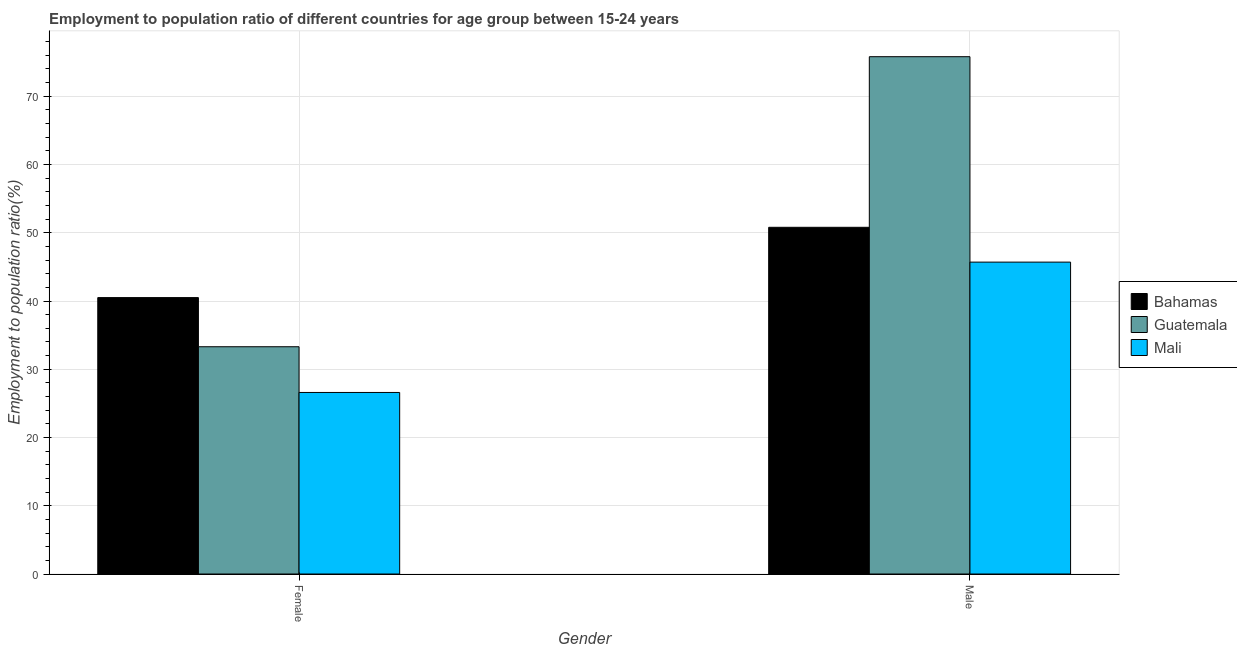How many groups of bars are there?
Offer a terse response. 2. Are the number of bars per tick equal to the number of legend labels?
Make the answer very short. Yes. Are the number of bars on each tick of the X-axis equal?
Keep it short and to the point. Yes. How many bars are there on the 2nd tick from the left?
Your response must be concise. 3. What is the label of the 2nd group of bars from the left?
Your response must be concise. Male. What is the employment to population ratio(female) in Mali?
Offer a terse response. 26.6. Across all countries, what is the maximum employment to population ratio(male)?
Give a very brief answer. 75.8. Across all countries, what is the minimum employment to population ratio(female)?
Offer a terse response. 26.6. In which country was the employment to population ratio(female) maximum?
Your answer should be very brief. Bahamas. In which country was the employment to population ratio(female) minimum?
Make the answer very short. Mali. What is the total employment to population ratio(female) in the graph?
Ensure brevity in your answer.  100.4. What is the difference between the employment to population ratio(female) in Bahamas and that in Mali?
Provide a short and direct response. 13.9. What is the difference between the employment to population ratio(female) in Bahamas and the employment to population ratio(male) in Guatemala?
Offer a terse response. -35.3. What is the average employment to population ratio(female) per country?
Ensure brevity in your answer.  33.47. What is the difference between the employment to population ratio(male) and employment to population ratio(female) in Bahamas?
Keep it short and to the point. 10.3. What is the ratio of the employment to population ratio(female) in Guatemala to that in Bahamas?
Your answer should be very brief. 0.82. In how many countries, is the employment to population ratio(male) greater than the average employment to population ratio(male) taken over all countries?
Offer a very short reply. 1. What does the 2nd bar from the left in Female represents?
Give a very brief answer. Guatemala. What does the 2nd bar from the right in Female represents?
Provide a short and direct response. Guatemala. Are all the bars in the graph horizontal?
Your response must be concise. No. What is the difference between two consecutive major ticks on the Y-axis?
Your answer should be compact. 10. Are the values on the major ticks of Y-axis written in scientific E-notation?
Offer a very short reply. No. Does the graph contain grids?
Provide a short and direct response. Yes. How are the legend labels stacked?
Offer a terse response. Vertical. What is the title of the graph?
Provide a succinct answer. Employment to population ratio of different countries for age group between 15-24 years. What is the label or title of the Y-axis?
Provide a succinct answer. Employment to population ratio(%). What is the Employment to population ratio(%) of Bahamas in Female?
Your response must be concise. 40.5. What is the Employment to population ratio(%) of Guatemala in Female?
Offer a terse response. 33.3. What is the Employment to population ratio(%) in Mali in Female?
Offer a very short reply. 26.6. What is the Employment to population ratio(%) of Bahamas in Male?
Your answer should be compact. 50.8. What is the Employment to population ratio(%) of Guatemala in Male?
Make the answer very short. 75.8. What is the Employment to population ratio(%) of Mali in Male?
Provide a succinct answer. 45.7. Across all Gender, what is the maximum Employment to population ratio(%) of Bahamas?
Make the answer very short. 50.8. Across all Gender, what is the maximum Employment to population ratio(%) in Guatemala?
Give a very brief answer. 75.8. Across all Gender, what is the maximum Employment to population ratio(%) in Mali?
Keep it short and to the point. 45.7. Across all Gender, what is the minimum Employment to population ratio(%) of Bahamas?
Give a very brief answer. 40.5. Across all Gender, what is the minimum Employment to population ratio(%) of Guatemala?
Provide a succinct answer. 33.3. Across all Gender, what is the minimum Employment to population ratio(%) in Mali?
Provide a short and direct response. 26.6. What is the total Employment to population ratio(%) in Bahamas in the graph?
Your answer should be compact. 91.3. What is the total Employment to population ratio(%) of Guatemala in the graph?
Keep it short and to the point. 109.1. What is the total Employment to population ratio(%) in Mali in the graph?
Offer a terse response. 72.3. What is the difference between the Employment to population ratio(%) of Guatemala in Female and that in Male?
Offer a terse response. -42.5. What is the difference between the Employment to population ratio(%) in Mali in Female and that in Male?
Make the answer very short. -19.1. What is the difference between the Employment to population ratio(%) of Bahamas in Female and the Employment to population ratio(%) of Guatemala in Male?
Your answer should be very brief. -35.3. What is the difference between the Employment to population ratio(%) in Bahamas in Female and the Employment to population ratio(%) in Mali in Male?
Provide a short and direct response. -5.2. What is the difference between the Employment to population ratio(%) in Guatemala in Female and the Employment to population ratio(%) in Mali in Male?
Your answer should be compact. -12.4. What is the average Employment to population ratio(%) in Bahamas per Gender?
Keep it short and to the point. 45.65. What is the average Employment to population ratio(%) of Guatemala per Gender?
Ensure brevity in your answer.  54.55. What is the average Employment to population ratio(%) of Mali per Gender?
Offer a very short reply. 36.15. What is the difference between the Employment to population ratio(%) of Bahamas and Employment to population ratio(%) of Mali in Female?
Keep it short and to the point. 13.9. What is the difference between the Employment to population ratio(%) of Guatemala and Employment to population ratio(%) of Mali in Female?
Your response must be concise. 6.7. What is the difference between the Employment to population ratio(%) in Bahamas and Employment to population ratio(%) in Guatemala in Male?
Offer a terse response. -25. What is the difference between the Employment to population ratio(%) in Bahamas and Employment to population ratio(%) in Mali in Male?
Your response must be concise. 5.1. What is the difference between the Employment to population ratio(%) in Guatemala and Employment to population ratio(%) in Mali in Male?
Give a very brief answer. 30.1. What is the ratio of the Employment to population ratio(%) of Bahamas in Female to that in Male?
Make the answer very short. 0.8. What is the ratio of the Employment to population ratio(%) in Guatemala in Female to that in Male?
Provide a short and direct response. 0.44. What is the ratio of the Employment to population ratio(%) in Mali in Female to that in Male?
Keep it short and to the point. 0.58. What is the difference between the highest and the second highest Employment to population ratio(%) of Guatemala?
Provide a succinct answer. 42.5. What is the difference between the highest and the second highest Employment to population ratio(%) in Mali?
Your answer should be very brief. 19.1. What is the difference between the highest and the lowest Employment to population ratio(%) in Guatemala?
Keep it short and to the point. 42.5. What is the difference between the highest and the lowest Employment to population ratio(%) of Mali?
Offer a very short reply. 19.1. 